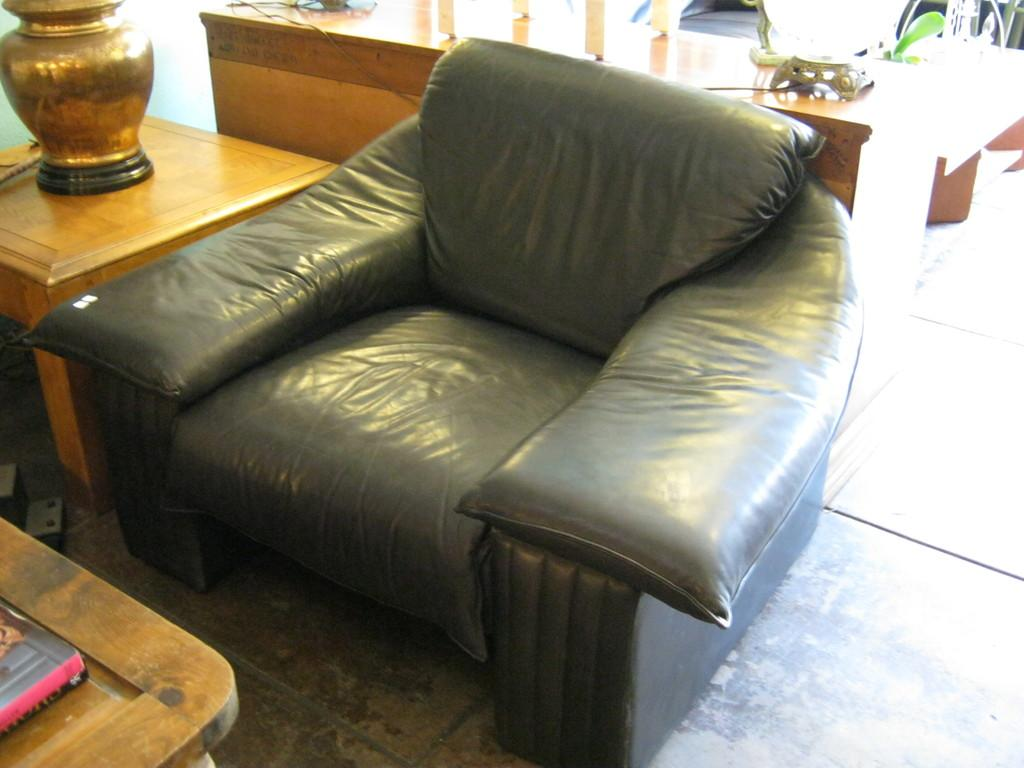What type of furniture is present in the image? There is a sofa and a table in the image. What part of the room can be seen in the image? The floor is visible in the image. What type of cave can be seen in the background of the image? There is no cave present in the image; it features a sofa, a table, and a visible floor. Can you describe the bird sitting on the desk in the image? There is no bird or desk present in the image. 